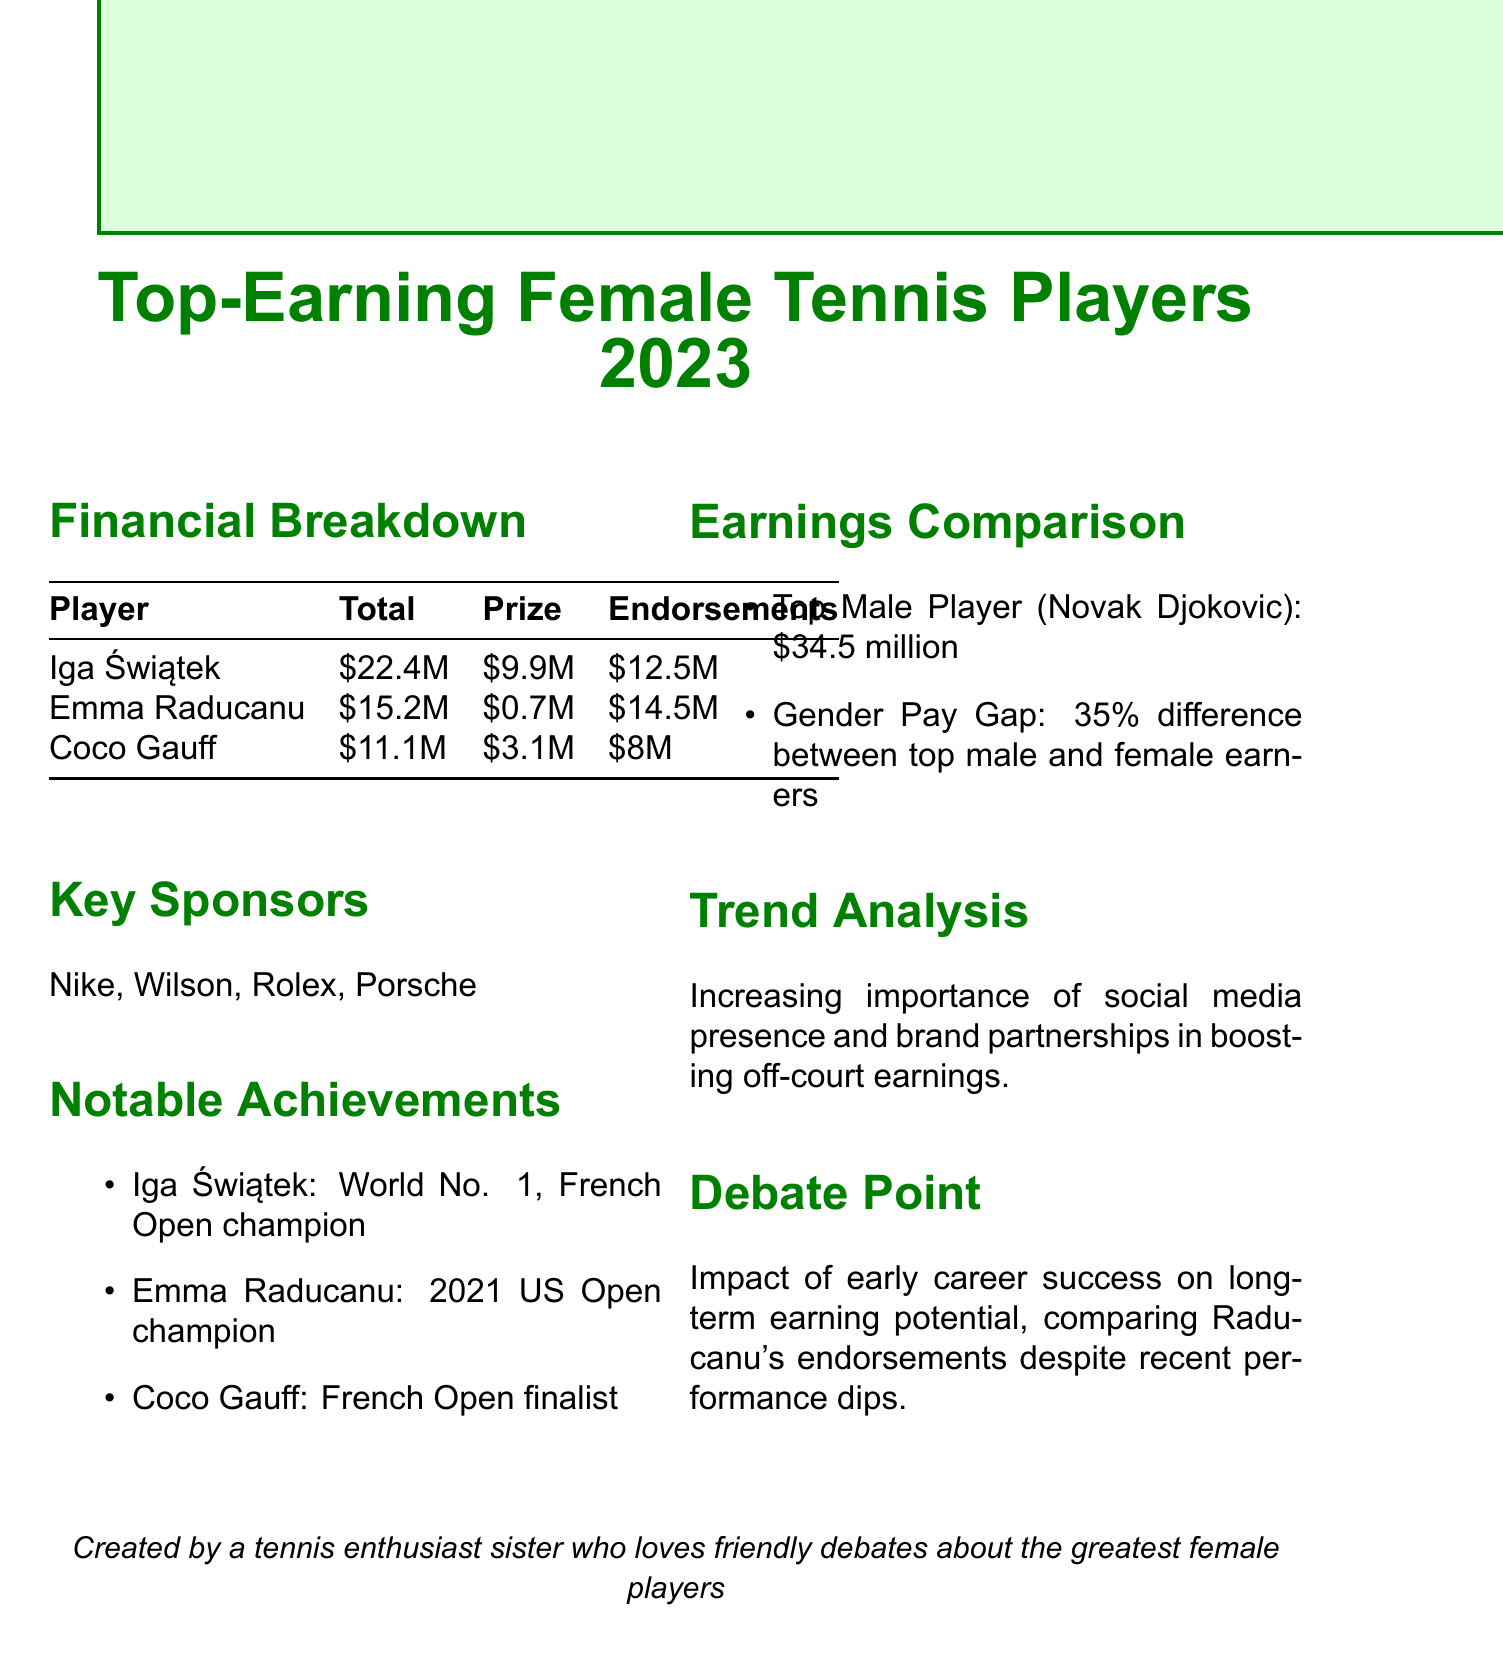what is Iga Świątek's total earnings? Iga Świątek's total earnings is specified in the document as $22.4 million.
Answer: $22.4 million what is Emma Raducanu's prize money? The document states that Emma Raducanu's prize money is $0.7 million.
Answer: $0.7 million who is the top male player by earnings? The document indicates that the top male player is Novak Djokovic.
Answer: Novak Djokovic what percentage is the gender pay gap referenced in the document? The gender pay gap mentioned in the document is 35%.
Answer: 35% which player is noted as World No. 1? The notable achievement listed for Iga Świątek in the document indicates she is World No. 1.
Answer: Iga Świątek how much did Coco Gauff earn in endorsements? According to the document, Coco Gauff earned $8 million in endorsements.
Answer: $8 million what is the trend analysis mentioned in the report? The document notes the increasing importance of social media presence and brand partnerships in boosting off-court earnings.
Answer: Increasing importance of social media presence and brand partnerships what notable achievement does Emma Raducanu hold? The document claims that Emma Raducanu is the 2021 US Open champion.
Answer: 2021 US Open champion what is the total earnings of Coco Gauff? The document lists Coco Gauff's total earnings as $11.1 million.
Answer: $11.1 million 